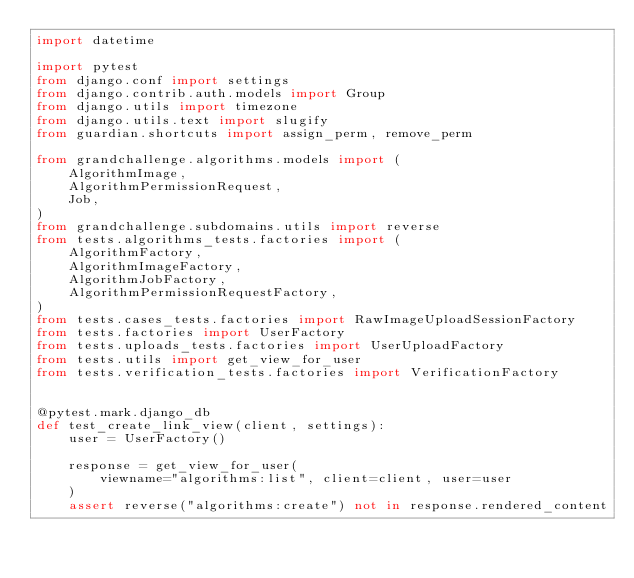<code> <loc_0><loc_0><loc_500><loc_500><_Python_>import datetime

import pytest
from django.conf import settings
from django.contrib.auth.models import Group
from django.utils import timezone
from django.utils.text import slugify
from guardian.shortcuts import assign_perm, remove_perm

from grandchallenge.algorithms.models import (
    AlgorithmImage,
    AlgorithmPermissionRequest,
    Job,
)
from grandchallenge.subdomains.utils import reverse
from tests.algorithms_tests.factories import (
    AlgorithmFactory,
    AlgorithmImageFactory,
    AlgorithmJobFactory,
    AlgorithmPermissionRequestFactory,
)
from tests.cases_tests.factories import RawImageUploadSessionFactory
from tests.factories import UserFactory
from tests.uploads_tests.factories import UserUploadFactory
from tests.utils import get_view_for_user
from tests.verification_tests.factories import VerificationFactory


@pytest.mark.django_db
def test_create_link_view(client, settings):
    user = UserFactory()

    response = get_view_for_user(
        viewname="algorithms:list", client=client, user=user
    )
    assert reverse("algorithms:create") not in response.rendered_content
</code> 